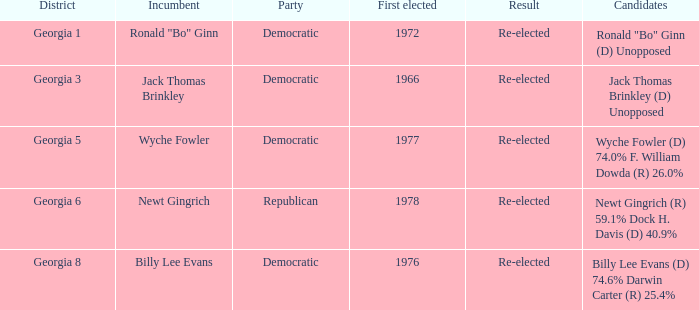How many parties supported candidates newt gingrich (r) 5 1.0. 